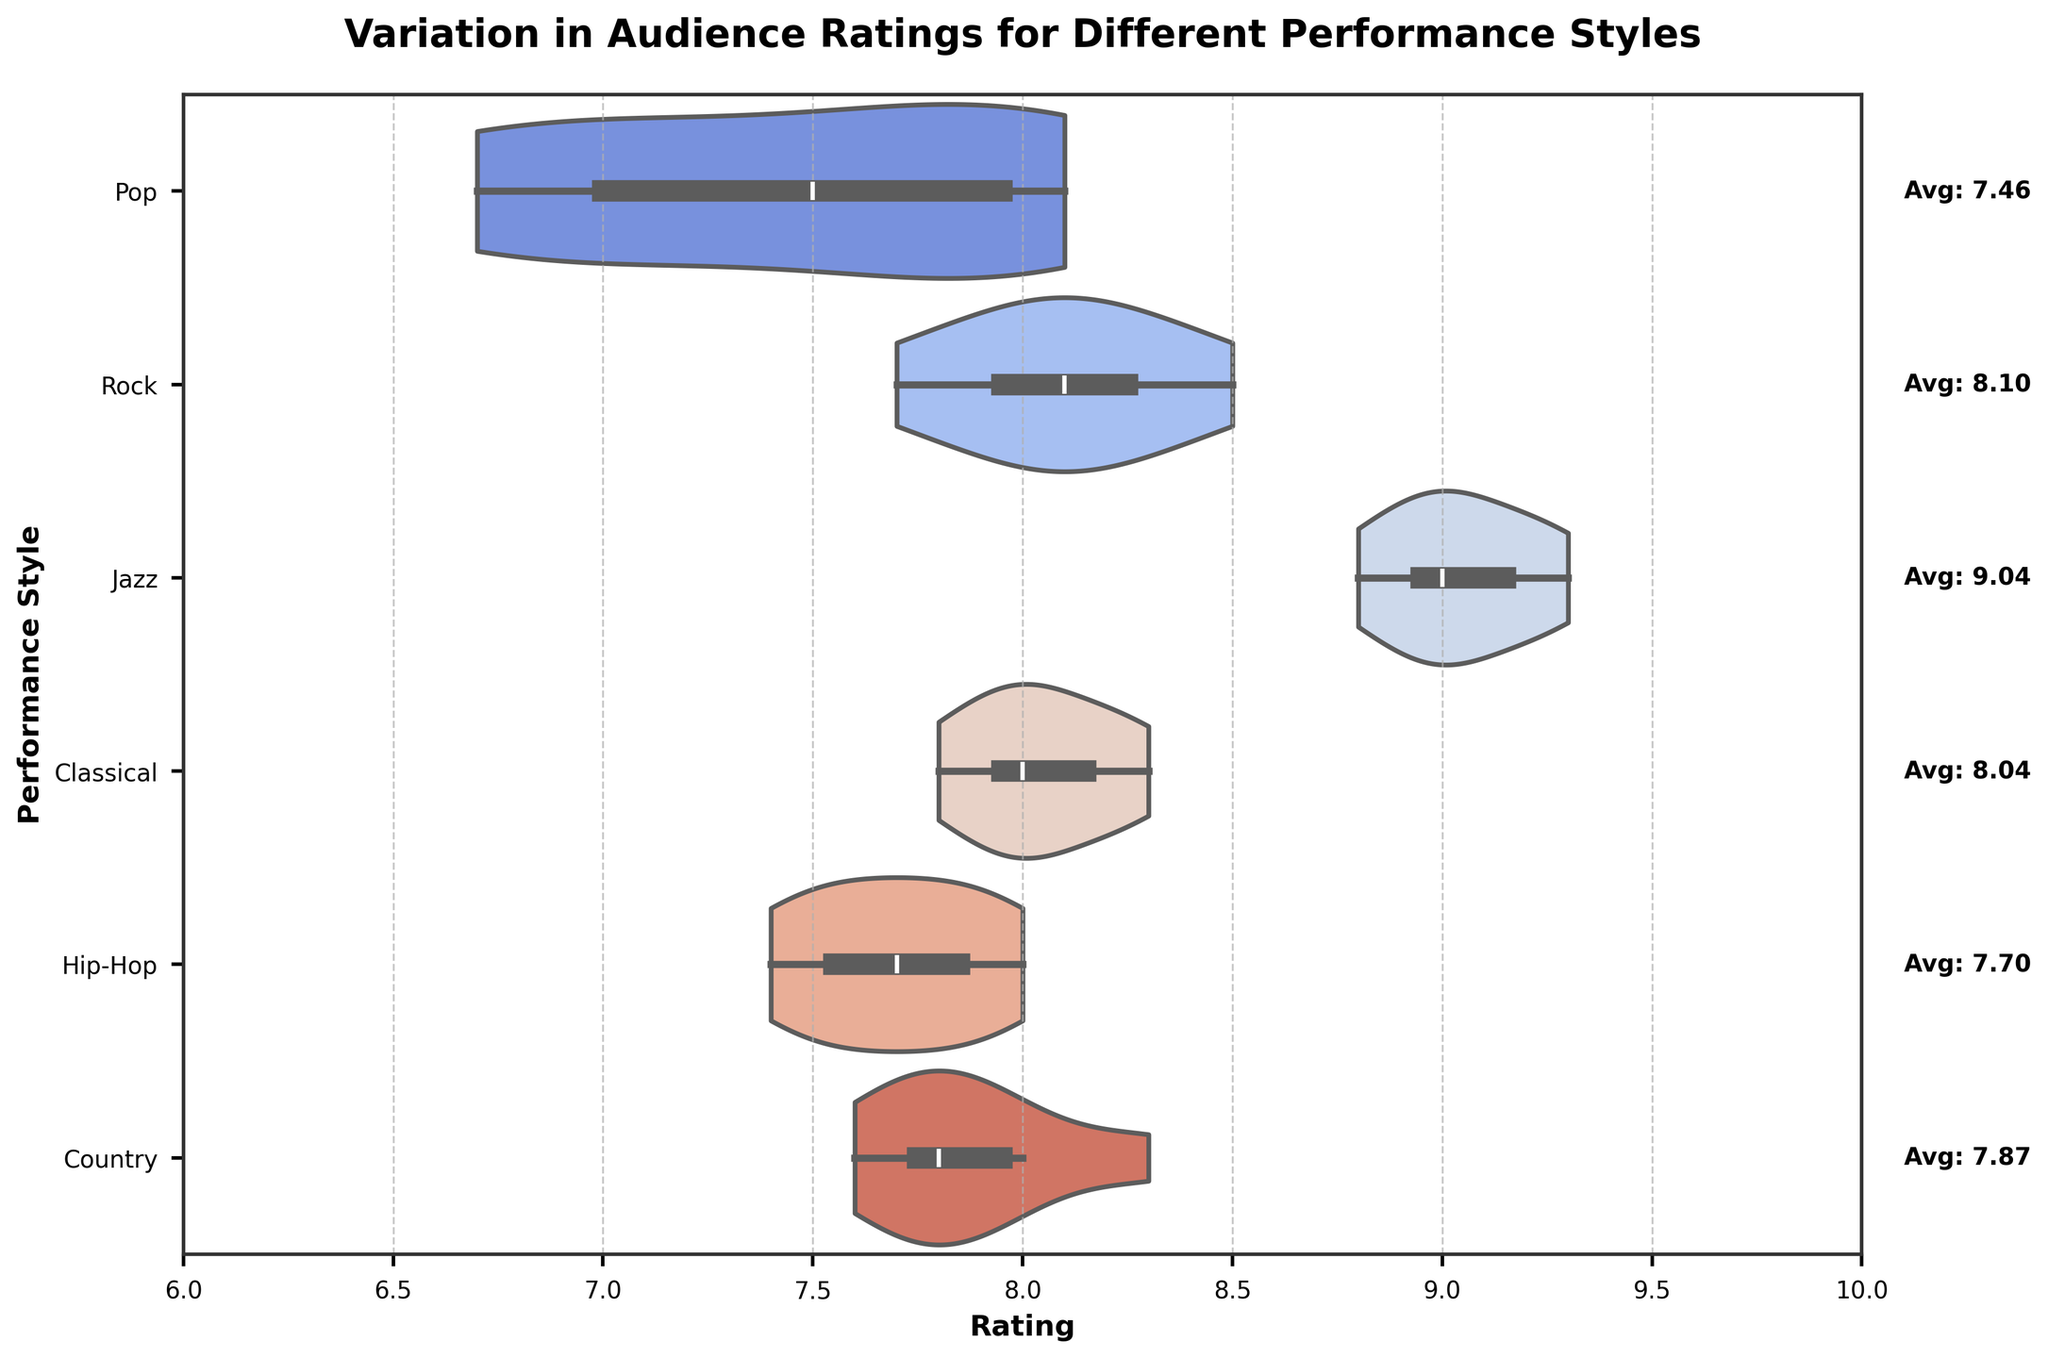What's the title of the figure? The title is located at the top of the figure and is usually in bold font to grab attention. In this case, it reads "Variation in Audience Ratings for Different Performance Styles".
Answer: Variation in Audience Ratings for Different Performance Styles What is the highest audience rating for Jazz? By observing the distribution of the violin plot for Jazz, the uppermost point of the plot represents the highest rating, which is at 9.3.
Answer: 9.3 Which performance style has the widest range of audience ratings? The width of the range can be deduced by noticing which violin plot is spread over the largest interval on the x-axis. Rock's ratings range from approximately 7.7 to 8.5.
Answer: Rock What is the average rating for Pop performances? The average rating for Pop performances is annotated next to the right side axis with the text "Avg: 7.60". This text provides the mean value.
Answer: 7.60 How do the rating distributions of Pop and Rock compare? By looking at the shape and spread of the Pop and Rock violin plots, we can see that Rock has a slightly higher and narrower distribution, indicating higher and more consistent ratings compared to the wider and lower spread of Pop ratings.
Answer: Rock has higher and more consistent ratings than Pop Which performance style has the lowest minimum rating? Observing the lower tip of each violin plot, the lowest point is found in the Pop plot at approximately 6.7.
Answer: Pop What's the difference in average audience ratings between Jazz and Hip-Hop performances? The annotation for Jazz shows an average rating of "Avg: 9.04" and for Hip-Hop "Avg: 7.70". The difference is calculated as 9.04 - 7.70 = 1.34.
Answer: 1.34 Between Classical and Country, which style has a higher median rating? The box inside each violin plot represents the interquartile range and the line inside the box represents the median. By comparing these lines, we see that the median of Classical (~8.0) is slightly lower than that of Country (~7.9).
Answer: Classical and Country have similar medians around 8.0 Which performance style has the smallest spread of ratings? The smallest spread refers to the narrowest distribution in the plot. Jazz has a very tight concentration of ratings around 9.0 to 9.3.
Answer: Jazz 